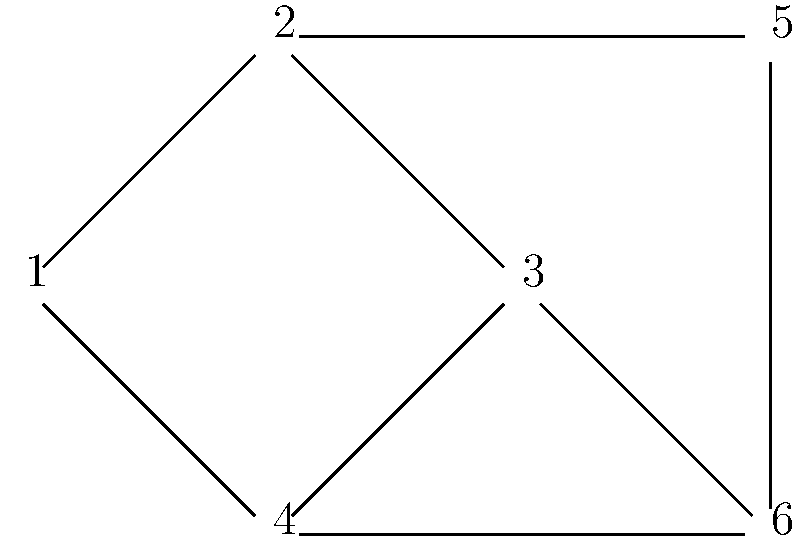In the given graph, identify all bridges and articulation points. How many bridges and articulation points are there in total? Let's approach this step-by-step:

1. Bridges:
   A bridge is an edge whose removal would disconnect the graph.
   - Edge (1-2): Removing this edge doesn't disconnect the graph.
   - Edge (1-4): Removing this edge doesn't disconnect the graph.
   - Edge (2-3): Removing this edge doesn't disconnect the graph.
   - Edge (2-5): Removing this edge doesn't disconnect the graph.
   - Edge (3-4): Removing this edge doesn't disconnect the graph.
   - Edge (3-6): Removing this edge doesn't disconnect the graph.
   - Edge (4-6): Removing this edge doesn't disconnect the graph.
   - Edge (5-6): Removing this edge doesn't disconnect the graph.

   There are no bridges in this graph.

2. Articulation Points:
   An articulation point is a vertex whose removal would disconnect the graph.
   - Vertex 1: Removing this vertex doesn't disconnect the graph.
   - Vertex 2: Removing this vertex disconnects vertex 1 from the rest of the graph.
   - Vertex 3: Removing this vertex doesn't disconnect the graph.
   - Vertex 4: Removing this vertex doesn't disconnect the graph.
   - Vertex 5: Removing this vertex doesn't disconnect the graph.
   - Vertex 6: Removing this vertex doesn't disconnect the graph.

   There is one articulation point: vertex 2.

Therefore, there are 0 bridges and 1 articulation point, totaling 1.
Answer: 1 (0 bridges, 1 articulation point) 